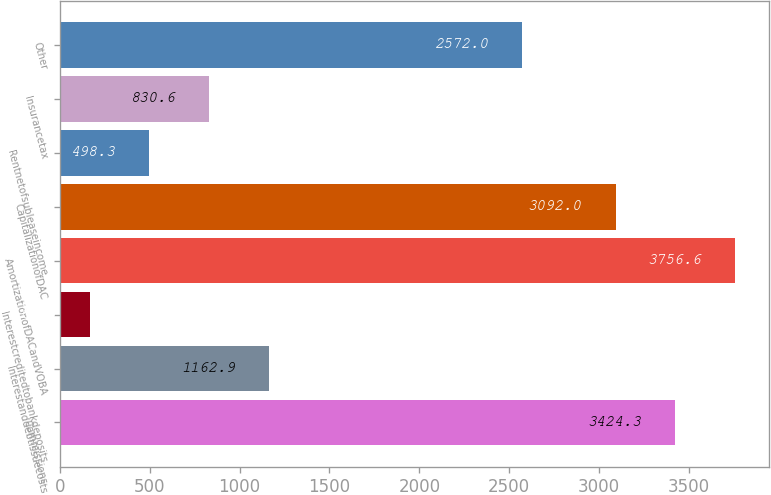<chart> <loc_0><loc_0><loc_500><loc_500><bar_chart><fcel>Commissions<fcel>Interestanddebtissuecosts<fcel>Interestcreditedtobankdeposits<fcel>AmortizationofDACandVOBA<fcel>CapitalizationofDAC<fcel>Rentnetofsubleaseincome<fcel>Insurancetax<fcel>Other<nl><fcel>3424.3<fcel>1162.9<fcel>166<fcel>3756.6<fcel>3092<fcel>498.3<fcel>830.6<fcel>2572<nl></chart> 